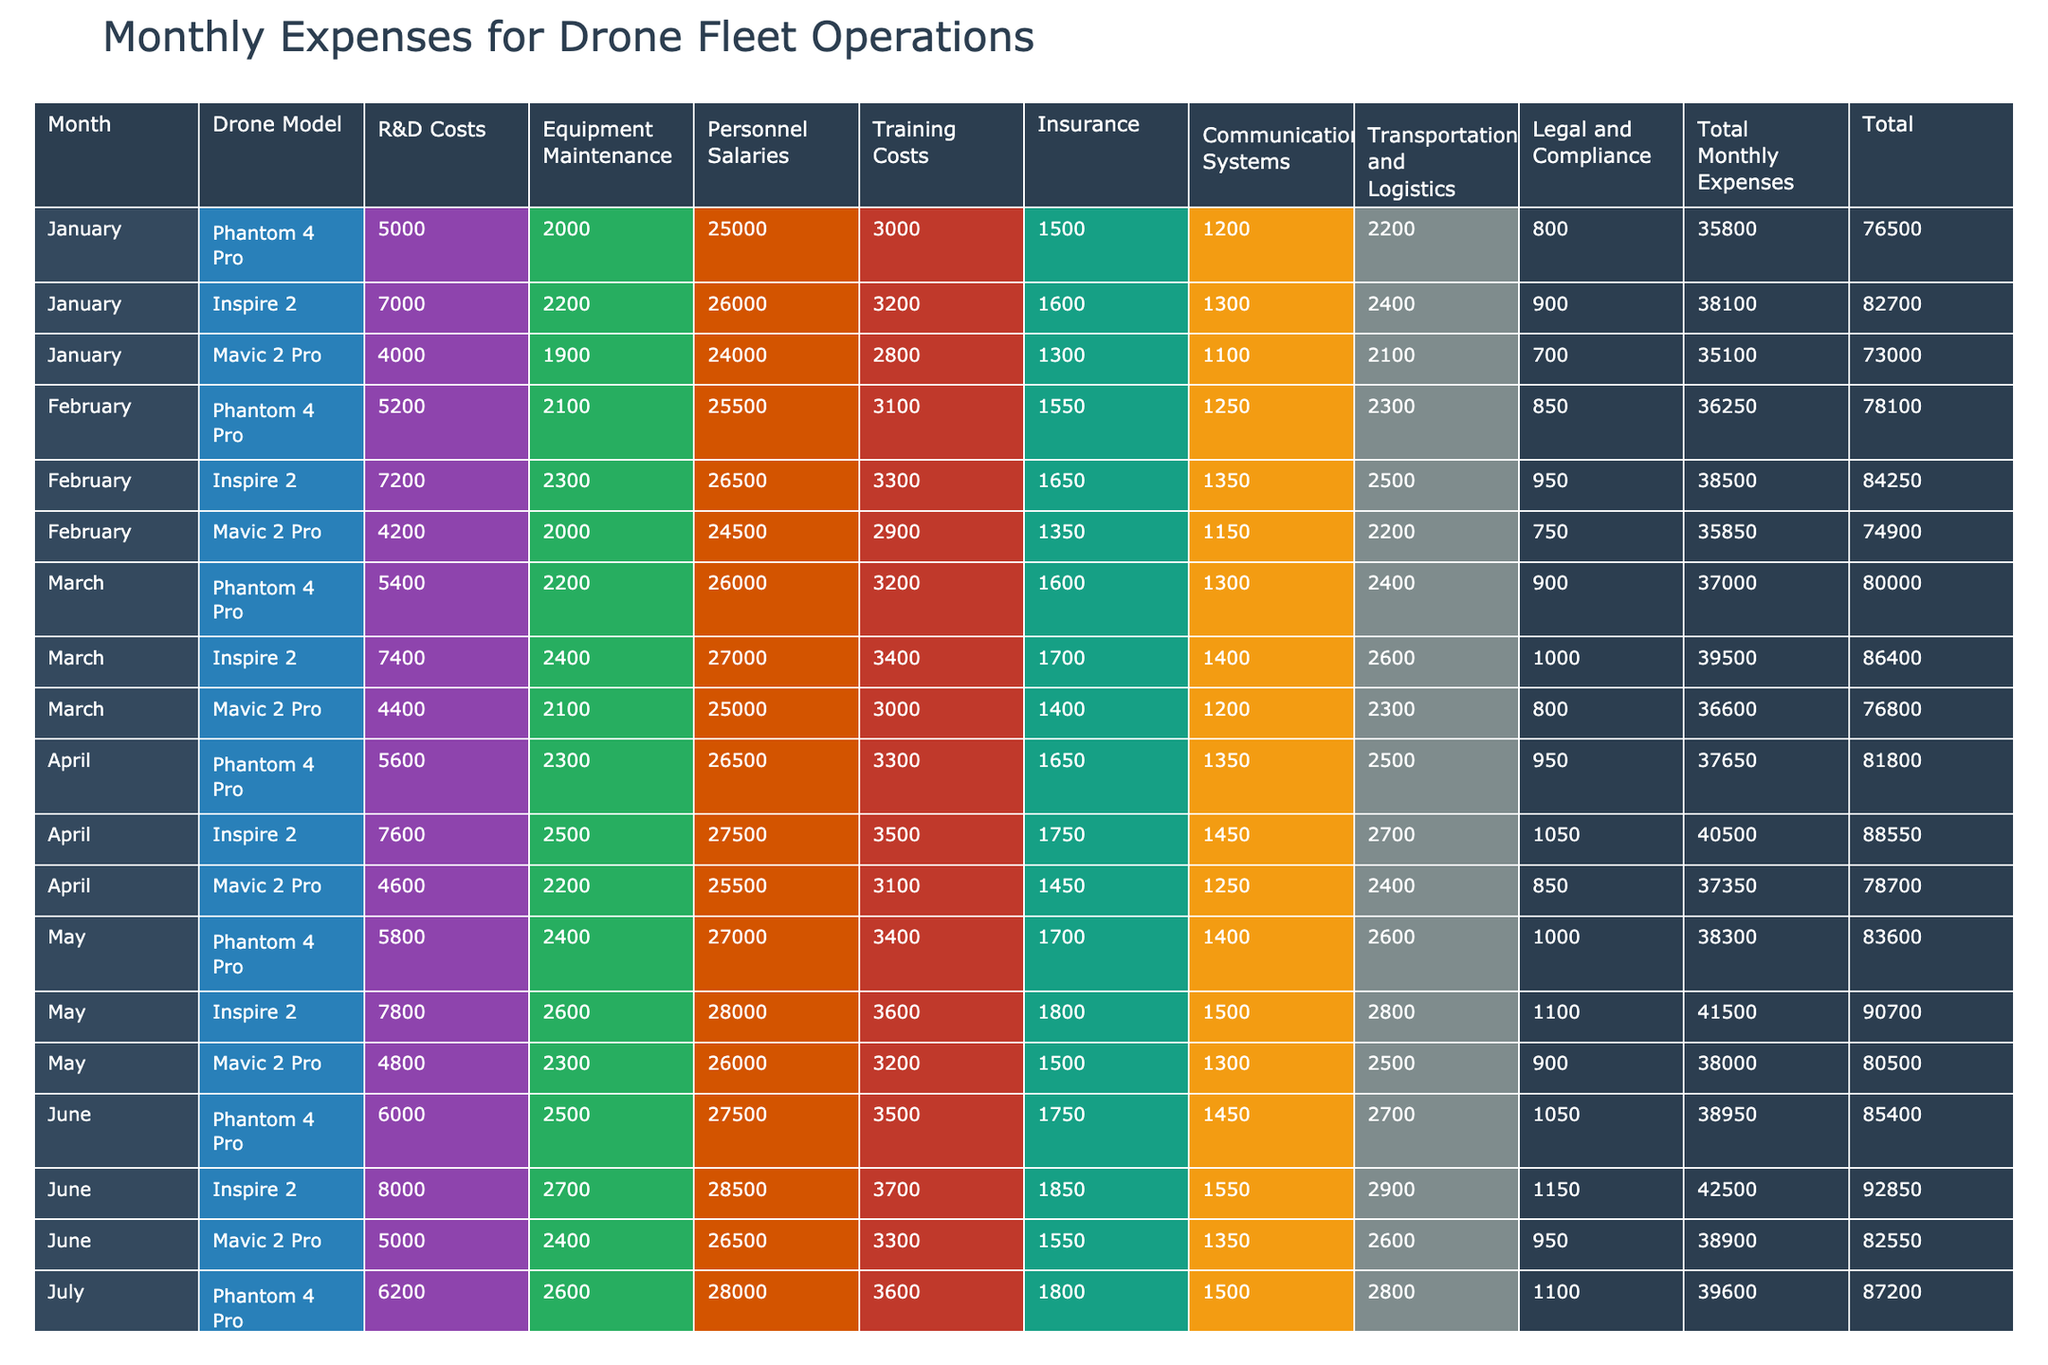What are the total expenses for the Inspire 2 model in July? From the table, the total expenses for the Inspire 2 in July are clearly listed in the respective row. It shows 43500 for July under the total column for this model.
Answer: 43500 What is the highest training cost recorded across all months for any drone model? By examining the "Training Costs" column for each month and model, the maximum training cost can be identified. The highest training cost is from the Inspire 2 in November at 4200.
Answer: 4200 Which drone model had the lowest total expenses in February? We can look at the total expenses for each drone model in February and identify the lowest value. The Mavic 2 Pro had total expenses of 35850, which is less than both Phantom 4 Pro (36250) and Inspire 2 (38500).
Answer: Mavic 2 Pro Did total expenses for the Phantom 4 Pro increase every month from January to December? We need to track the monthly totals for Phantom 4 Pro from January (35800) through December (42850). Observing the totals shows a consistent increase every month, confirming that total expenses did indeed increase.
Answer: Yes What is the average total monthly expense for all drone models in October? To find the average, we first add the total monthly expenses for all models in October: 41550 (Phantom 4 Pro) + 46550 (Inspire 2) + 41550 (Mavic 2 Pro) = 129550, then divide by the number of models which is 3. Thus, 129550 / 3 = 43183.33. Rounded, the average is 43183.
Answer: 43183 Which month showed the highest total monthly expense for Mavic 2 Pro? We inspect the total monthly expenses for Mavic 2 Pro across each month. The highest total expense is observed in June at 38900, which is higher than reported totals in other months.
Answer: June What is the difference in total expenses between the highest and lowest costing models in March? In March, the total expenses for Inspire 2 are 39500 (highest), and for Mavic 2 Pro they are 36600 (lowest). Calculating the difference: 39500 - 36600 = 2900.
Answer: 2900 Is the total monthly expense for any model in December lower than 42000? In December, the totalexpenses for Phantom 4 Pro is 42850, for Inspire 2 is 48550, and for Mavic 2 Pro is 42850. None of these expenses fall below 42000, which means the answer is "No".
Answer: No What was the trend in insurance costs for the Inspire 2 model from January to June? By examining the "Insurance" column for Inspire 2 from January (1600) to June (1850), we notice that the values increase month by month: 1600, 1650, 1700, 1750, 1800, and 1850. This indicates a consistent increasing trend over these months.
Answer: Increasing 